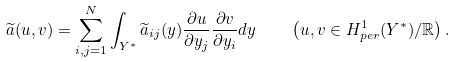<formula> <loc_0><loc_0><loc_500><loc_500>\widetilde { a } ( u , v ) = \sum _ { i , j = 1 } ^ { N } \int _ { Y ^ { * } } \widetilde { a } _ { i j } ( y ) \frac { \partial u } { \partial y _ { j } } \frac { \partial v } { \partial y _ { i } } d y \quad \left ( u , v \in H ^ { 1 } _ { p e r } ( Y ^ { * } ) / \mathbb { R } \right ) .</formula> 